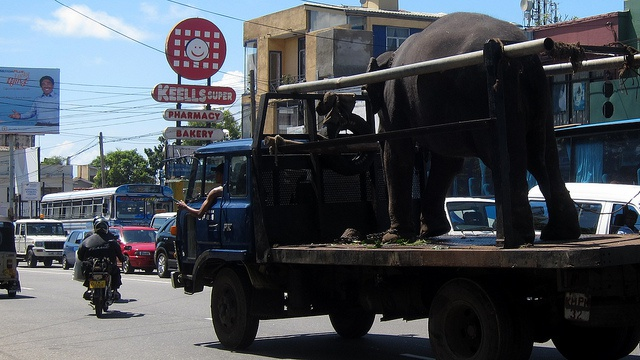Describe the objects in this image and their specific colors. I can see truck in lightblue, black, gray, darkgray, and navy tones, elephant in lightblue, black, and gray tones, bus in lightblue, black, gray, navy, and lightgray tones, car in lightblue, white, black, darkblue, and blue tones, and truck in lightblue, black, gray, lightgray, and darkgray tones in this image. 